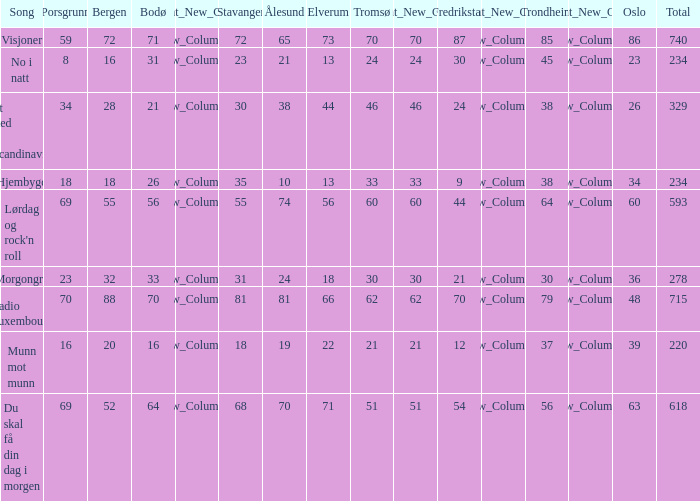Would you be able to parse every entry in this table? {'header': ['Song', 'Porsgrunn', 'Bergen', 'Bodø', 'Relevant_New_Column1', 'Stavanger', 'Ålesund', 'Elverum', 'Tromsø', 'Relevant_New_Column2', 'Fredrikstad', 'Relevant_New_Column3', 'Trondheim', 'Relevant_New_Column4', 'Oslo', 'Total'], 'rows': [['Visjoner', '59', '72', '71', 'New_Column_1', '72', '65', '73', '70', '70', '87', 'New_Column_3', '85', 'New_Column_4', '86', '740'], ['No i natt', '8', '16', '31', 'New_Column_1', '23', '21', '13', '24', '24', '30', 'New_Column_3', '45', 'New_Column_4', '23', '234'], ['Et sted i Scandinavia', '34', '28', '21', 'New_Column_1', '30', '38', '44', '46', '46', '24', 'New_Column_3', '38', 'New_Column_4', '26', '329'], ['Hjembygd', '18', '18', '26', 'New_Column_1', '35', '10', '13', '33', '33', '9', 'New_Column_3', '38', 'New_Column_4', '34', '234'], ["Lørdag og rock'n roll", '69', '55', '56', 'New_Column_1', '55', '74', '56', '60', '60', '44', 'New_Column_3', '64', 'New_Column_4', '60', '593'], ['Morgongry', '23', '32', '33', 'New_Column_1', '31', '24', '18', '30', '30', '21', 'New_Column_3', '30', 'New_Column_4', '36', '278'], ['Radio Luxembourg', '70', '88', '70', 'New_Column_1', '81', '81', '66', '62', '62', '70', 'New_Column_3', '79', 'New_Column_4', '48', '715'], ['Munn mot munn', '16', '20', '16', 'New_Column_1', '18', '19', '22', '21', '21', '12', 'New_Column_3', '37', 'New_Column_4', '39', '220'], ['Du skal få din dag i morgen', '69', '52', '64', 'New_Column_1', '68', '70', '71', '51', '51', '54', 'New_Column_3', '56', 'New_Column_4', '63', '618']]} When the combined score amounts to 740, what does tromso represent? 70.0. 